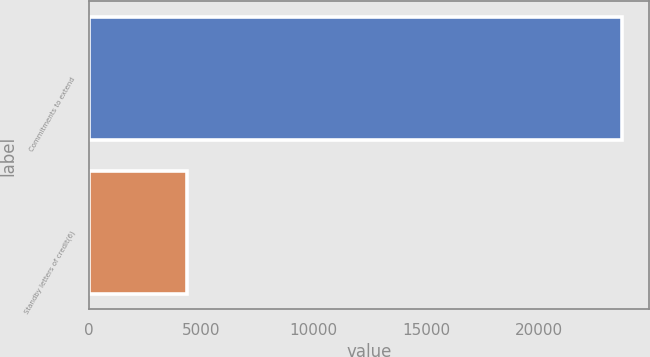Convert chart. <chart><loc_0><loc_0><loc_500><loc_500><bar_chart><fcel>Commitments to extend<fcel>Standby letters of credit(6)<nl><fcel>23715<fcel>4376<nl></chart> 